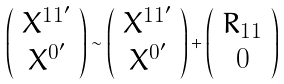<formula> <loc_0><loc_0><loc_500><loc_500>\left ( \begin{array} { c } X ^ { 1 1 ^ { \prime } } \\ X ^ { 0 ^ { \prime } } \end{array} \right ) \sim \left ( \begin{array} { c } X ^ { 1 1 ^ { \prime } } \\ X ^ { 0 ^ { \prime } } \end{array} \right ) + \left ( \begin{array} { c } R _ { 1 1 } \\ 0 \end{array} \right )</formula> 